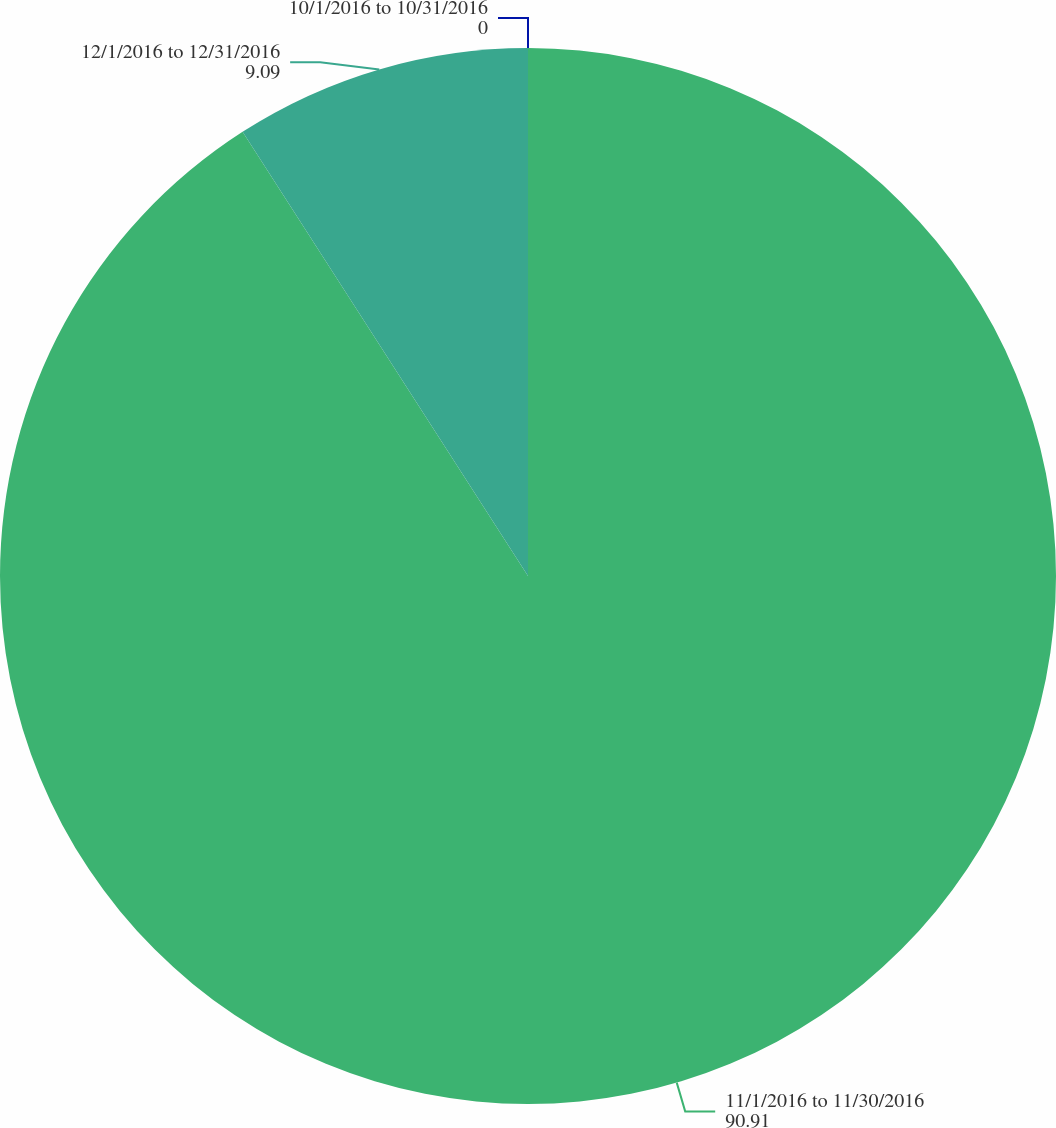Convert chart to OTSL. <chart><loc_0><loc_0><loc_500><loc_500><pie_chart><fcel>10/1/2016 to 10/31/2016<fcel>11/1/2016 to 11/30/2016<fcel>12/1/2016 to 12/31/2016<nl><fcel>0.0%<fcel>90.91%<fcel>9.09%<nl></chart> 